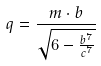<formula> <loc_0><loc_0><loc_500><loc_500>q = \frac { m \cdot b } { \sqrt { 6 - \frac { b ^ { 7 } } { c ^ { 7 } } } }</formula> 